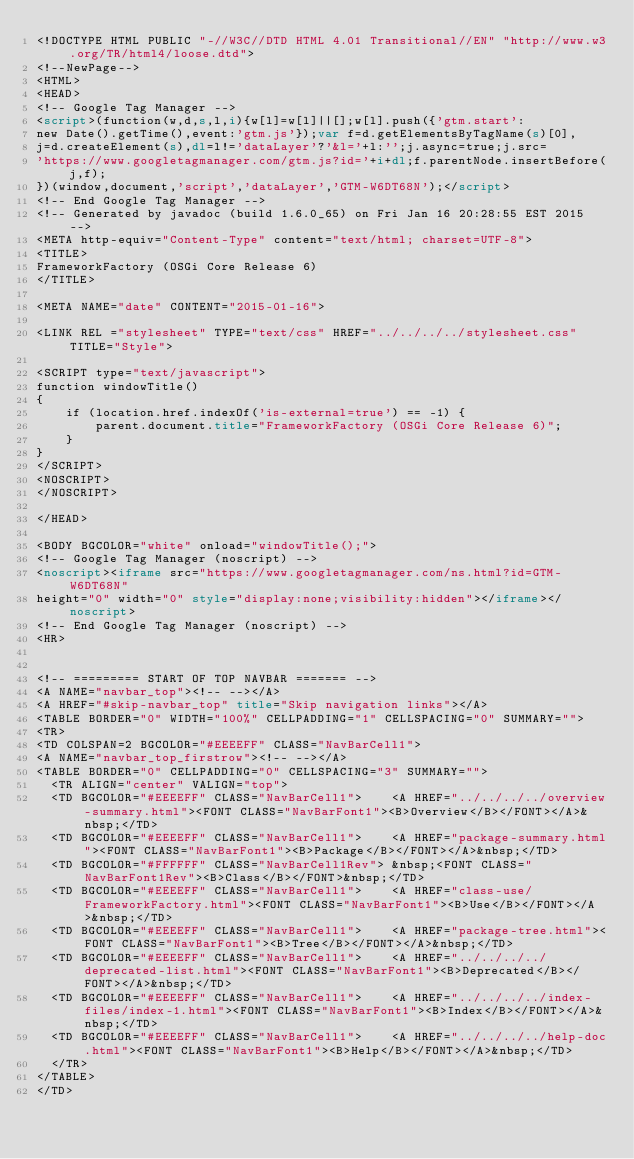Convert code to text. <code><loc_0><loc_0><loc_500><loc_500><_HTML_><!DOCTYPE HTML PUBLIC "-//W3C//DTD HTML 4.01 Transitional//EN" "http://www.w3.org/TR/html4/loose.dtd">
<!--NewPage-->
<HTML>
<HEAD>
<!-- Google Tag Manager -->
<script>(function(w,d,s,l,i){w[l]=w[l]||[];w[l].push({'gtm.start':
new Date().getTime(),event:'gtm.js'});var f=d.getElementsByTagName(s)[0],
j=d.createElement(s),dl=l!='dataLayer'?'&l='+l:'';j.async=true;j.src=
'https://www.googletagmanager.com/gtm.js?id='+i+dl;f.parentNode.insertBefore(j,f);
})(window,document,'script','dataLayer','GTM-W6DT68N');</script>
<!-- End Google Tag Manager -->
<!-- Generated by javadoc (build 1.6.0_65) on Fri Jan 16 20:28:55 EST 2015 -->
<META http-equiv="Content-Type" content="text/html; charset=UTF-8">
<TITLE>
FrameworkFactory (OSGi Core Release 6)
</TITLE>

<META NAME="date" CONTENT="2015-01-16">

<LINK REL ="stylesheet" TYPE="text/css" HREF="../../../../stylesheet.css" TITLE="Style">

<SCRIPT type="text/javascript">
function windowTitle()
{
    if (location.href.indexOf('is-external=true') == -1) {
        parent.document.title="FrameworkFactory (OSGi Core Release 6)";
    }
}
</SCRIPT>
<NOSCRIPT>
</NOSCRIPT>

</HEAD>

<BODY BGCOLOR="white" onload="windowTitle();">
<!-- Google Tag Manager (noscript) -->
<noscript><iframe src="https://www.googletagmanager.com/ns.html?id=GTM-W6DT68N"
height="0" width="0" style="display:none;visibility:hidden"></iframe></noscript>
<!-- End Google Tag Manager (noscript) -->
<HR>


<!-- ========= START OF TOP NAVBAR ======= -->
<A NAME="navbar_top"><!-- --></A>
<A HREF="#skip-navbar_top" title="Skip navigation links"></A>
<TABLE BORDER="0" WIDTH="100%" CELLPADDING="1" CELLSPACING="0" SUMMARY="">
<TR>
<TD COLSPAN=2 BGCOLOR="#EEEEFF" CLASS="NavBarCell1">
<A NAME="navbar_top_firstrow"><!-- --></A>
<TABLE BORDER="0" CELLPADDING="0" CELLSPACING="3" SUMMARY="">
  <TR ALIGN="center" VALIGN="top">
  <TD BGCOLOR="#EEEEFF" CLASS="NavBarCell1">    <A HREF="../../../../overview-summary.html"><FONT CLASS="NavBarFont1"><B>Overview</B></FONT></A>&nbsp;</TD>
  <TD BGCOLOR="#EEEEFF" CLASS="NavBarCell1">    <A HREF="package-summary.html"><FONT CLASS="NavBarFont1"><B>Package</B></FONT></A>&nbsp;</TD>
  <TD BGCOLOR="#FFFFFF" CLASS="NavBarCell1Rev"> &nbsp;<FONT CLASS="NavBarFont1Rev"><B>Class</B></FONT>&nbsp;</TD>
  <TD BGCOLOR="#EEEEFF" CLASS="NavBarCell1">    <A HREF="class-use/FrameworkFactory.html"><FONT CLASS="NavBarFont1"><B>Use</B></FONT></A>&nbsp;</TD>
  <TD BGCOLOR="#EEEEFF" CLASS="NavBarCell1">    <A HREF="package-tree.html"><FONT CLASS="NavBarFont1"><B>Tree</B></FONT></A>&nbsp;</TD>
  <TD BGCOLOR="#EEEEFF" CLASS="NavBarCell1">    <A HREF="../../../../deprecated-list.html"><FONT CLASS="NavBarFont1"><B>Deprecated</B></FONT></A>&nbsp;</TD>
  <TD BGCOLOR="#EEEEFF" CLASS="NavBarCell1">    <A HREF="../../../../index-files/index-1.html"><FONT CLASS="NavBarFont1"><B>Index</B></FONT></A>&nbsp;</TD>
  <TD BGCOLOR="#EEEEFF" CLASS="NavBarCell1">    <A HREF="../../../../help-doc.html"><FONT CLASS="NavBarFont1"><B>Help</B></FONT></A>&nbsp;</TD>
  </TR>
</TABLE>
</TD></code> 